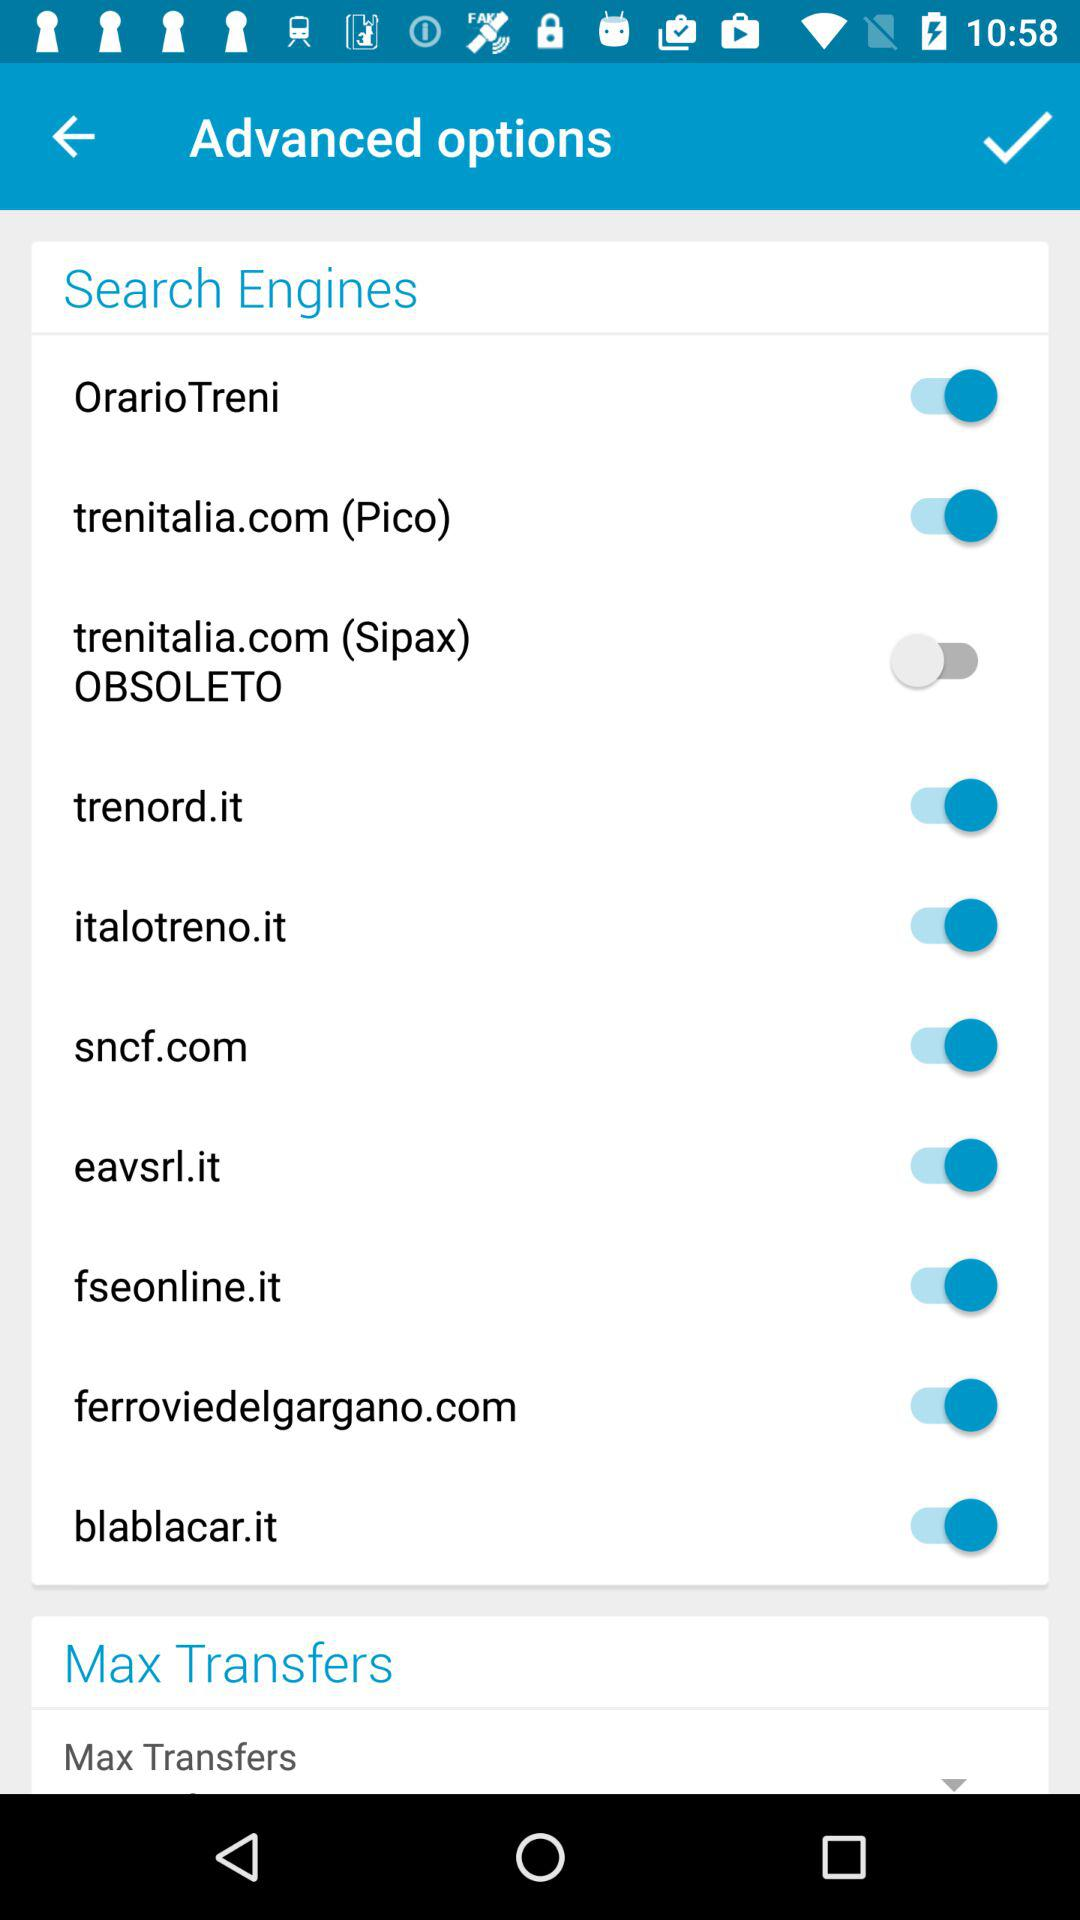What is the status of the "sncf.com"? The status is "on". 